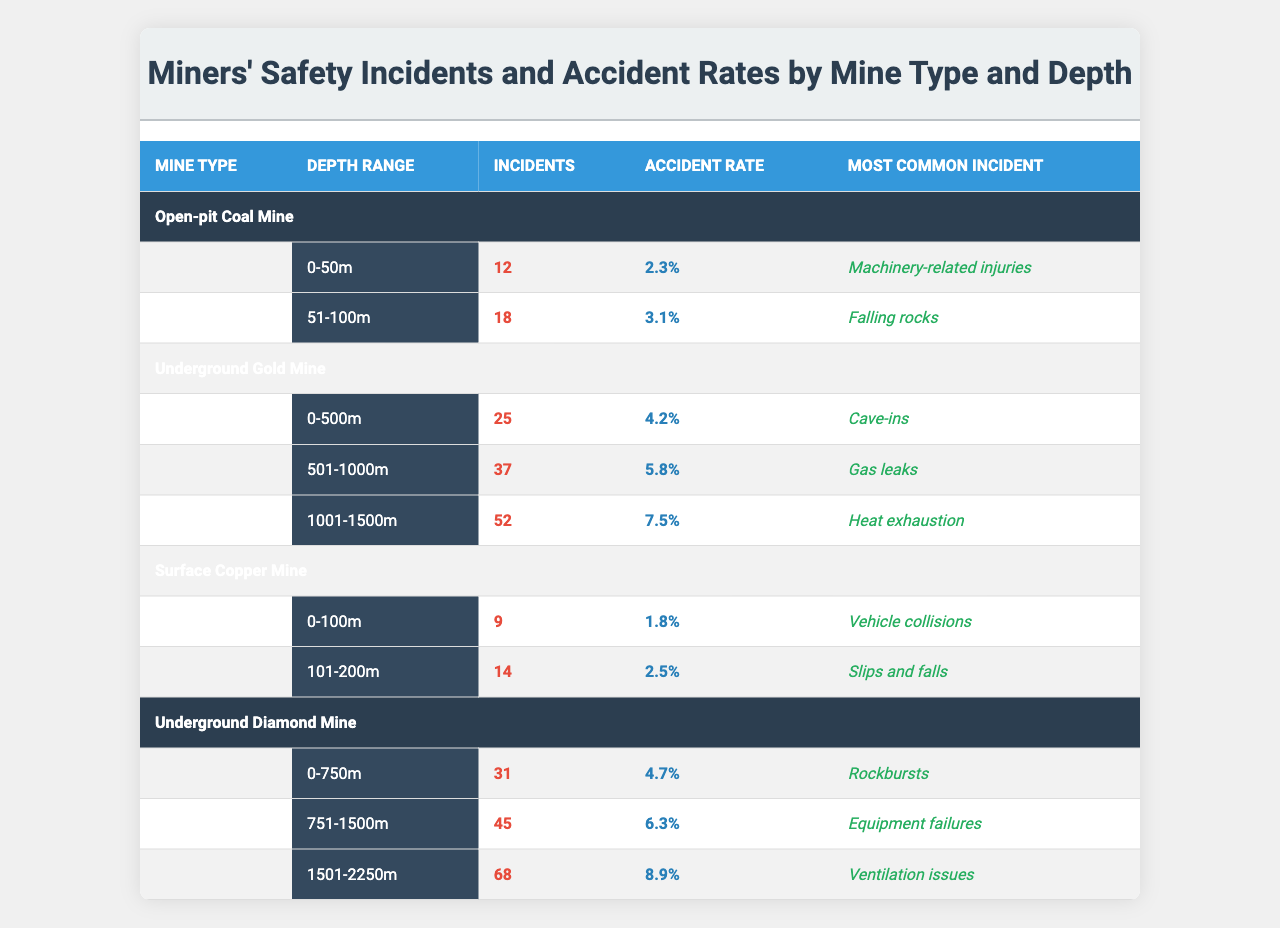What is the most common incident in Open-pit Coal Mines at depths of 0-50m? Referring to the table, the most common incident listed for Open-pit Coal Mines in the depth range of 0-50m is "Machinery-related injuries."
Answer: Machinery-related injuries How many incidents occurred in Underground Gold Mines between 501-1000m? The table shows that in Underground Gold Mines within the depth range of 501-1000m, there were 37 incidents.
Answer: 37 What is the accident rate in Surface Copper Mines at depths of 101-200m? According to the table, the accident rate for Surface Copper Mines at the depth range of 101-200m is 2.5%.
Answer: 2.5% What is the total number of incidents across all Underground Diamond Mine depth ranges? By adding the incidents from the three depth ranges for Underground Diamond Mines: (31 + 45 + 68) = 144.
Answer: 144 Which mine type has the highest incident rate based on the maximum depth? The Underground Diamond Mine at 1501-2250m has an accident rate of 8.9%, which is the highest compared to other mine types at their maximum depths.
Answer: Underground Diamond Mine Is the accident rate for Open-pit Coal Mines at 51-100m greater than that of Surface Copper Mines at 0-100m? Yes, Open-pit Coal Mines at 51-100m have a 3.1% accident rate, which is greater than the 1.8% accident rate for Surface Copper Mines at 0-100m.
Answer: Yes What is the average accident rate of all the depth ranges for Underground Gold Mines? Calculating the average: (4.2% + 5.8% + 7.5%) / 3 = 5.23%.
Answer: 5.23% Which type of mine and depth range has the lowest number of incidents? The Surface Copper Mine at 0-100m has the lowest number of incidents, with a total of 9 incidents.
Answer: Surface Copper Mine at 0-100m How many total incidents were recorded in all mines at depths shallower than 50m? The only mine type at a depth shallower than 50m is Open-pit Coal Mine, which recorded 12 incidents. No other mine types report incidents at this depth.
Answer: 12 